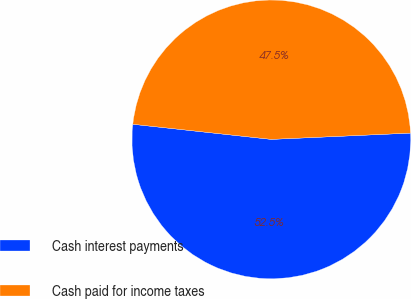Convert chart to OTSL. <chart><loc_0><loc_0><loc_500><loc_500><pie_chart><fcel>Cash interest payments<fcel>Cash paid for income taxes<nl><fcel>52.45%<fcel>47.55%<nl></chart> 